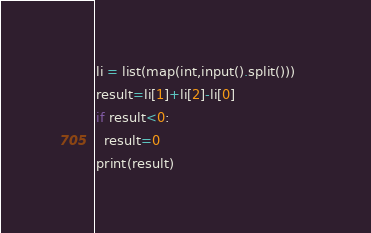<code> <loc_0><loc_0><loc_500><loc_500><_Python_>li = list(map(int,input().split()))	
result=li[1]+li[2]-li[0]
if result<0:
  result=0
print(result)</code> 